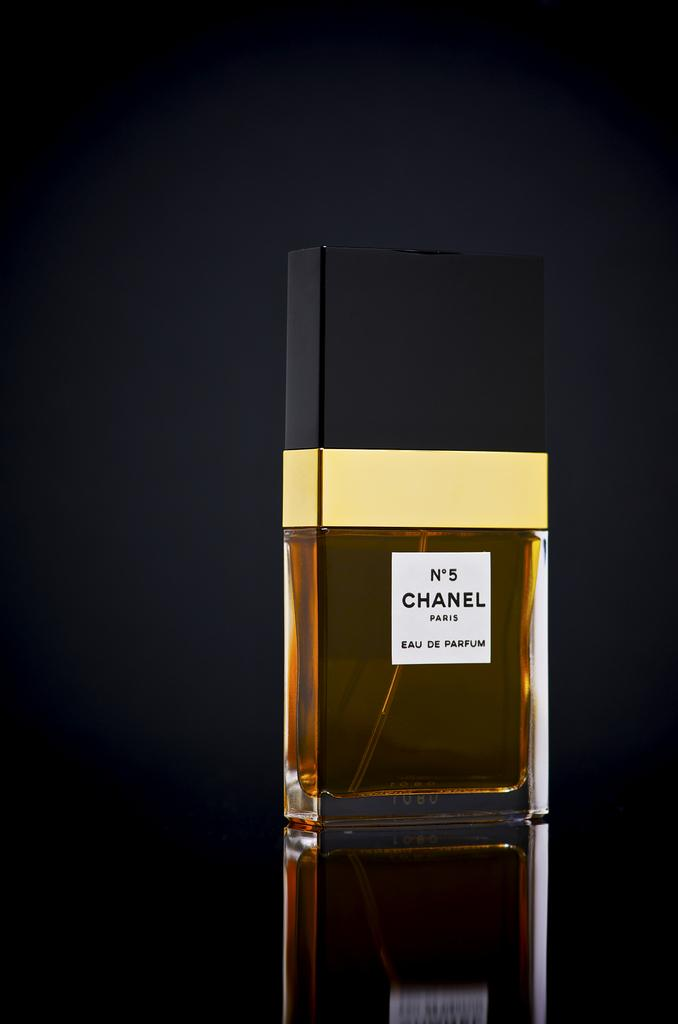<image>
Create a compact narrative representing the image presented. A chanel perfume is on a display against the black background. 